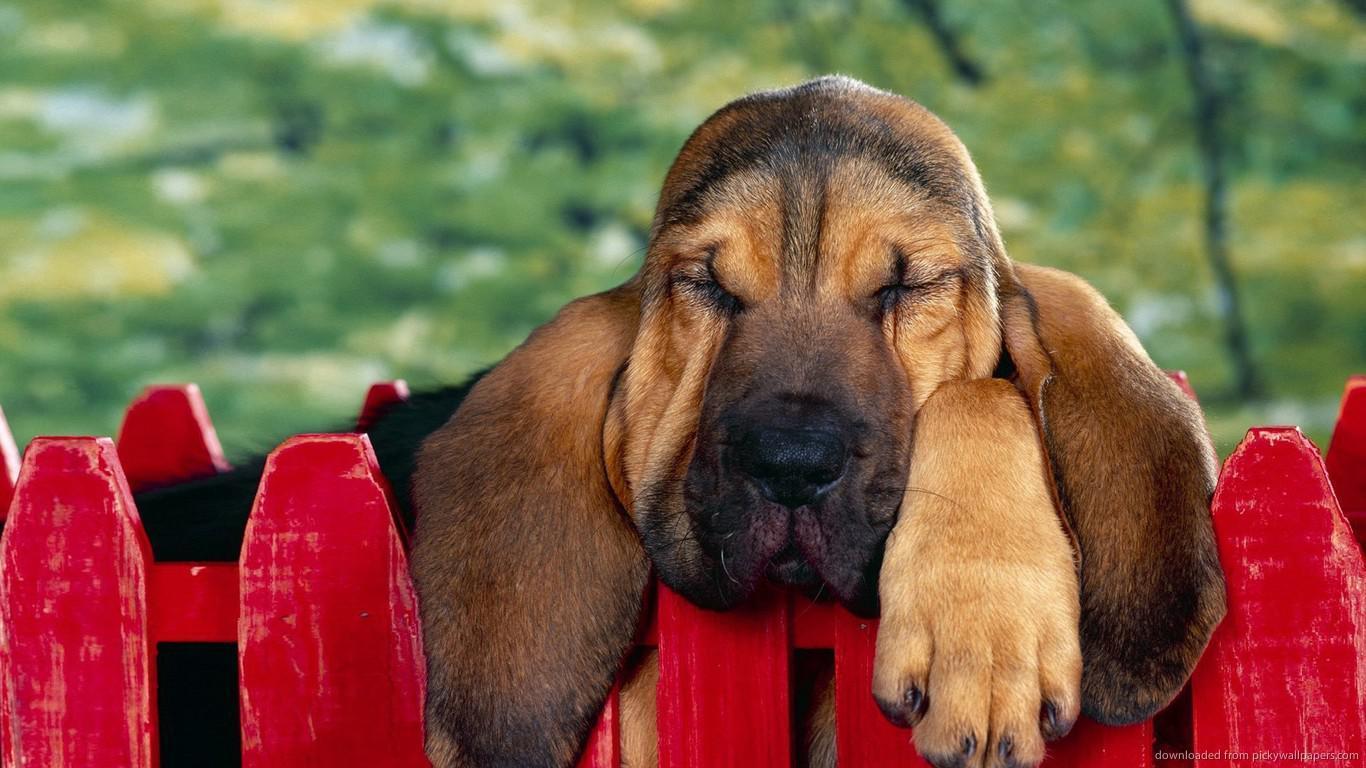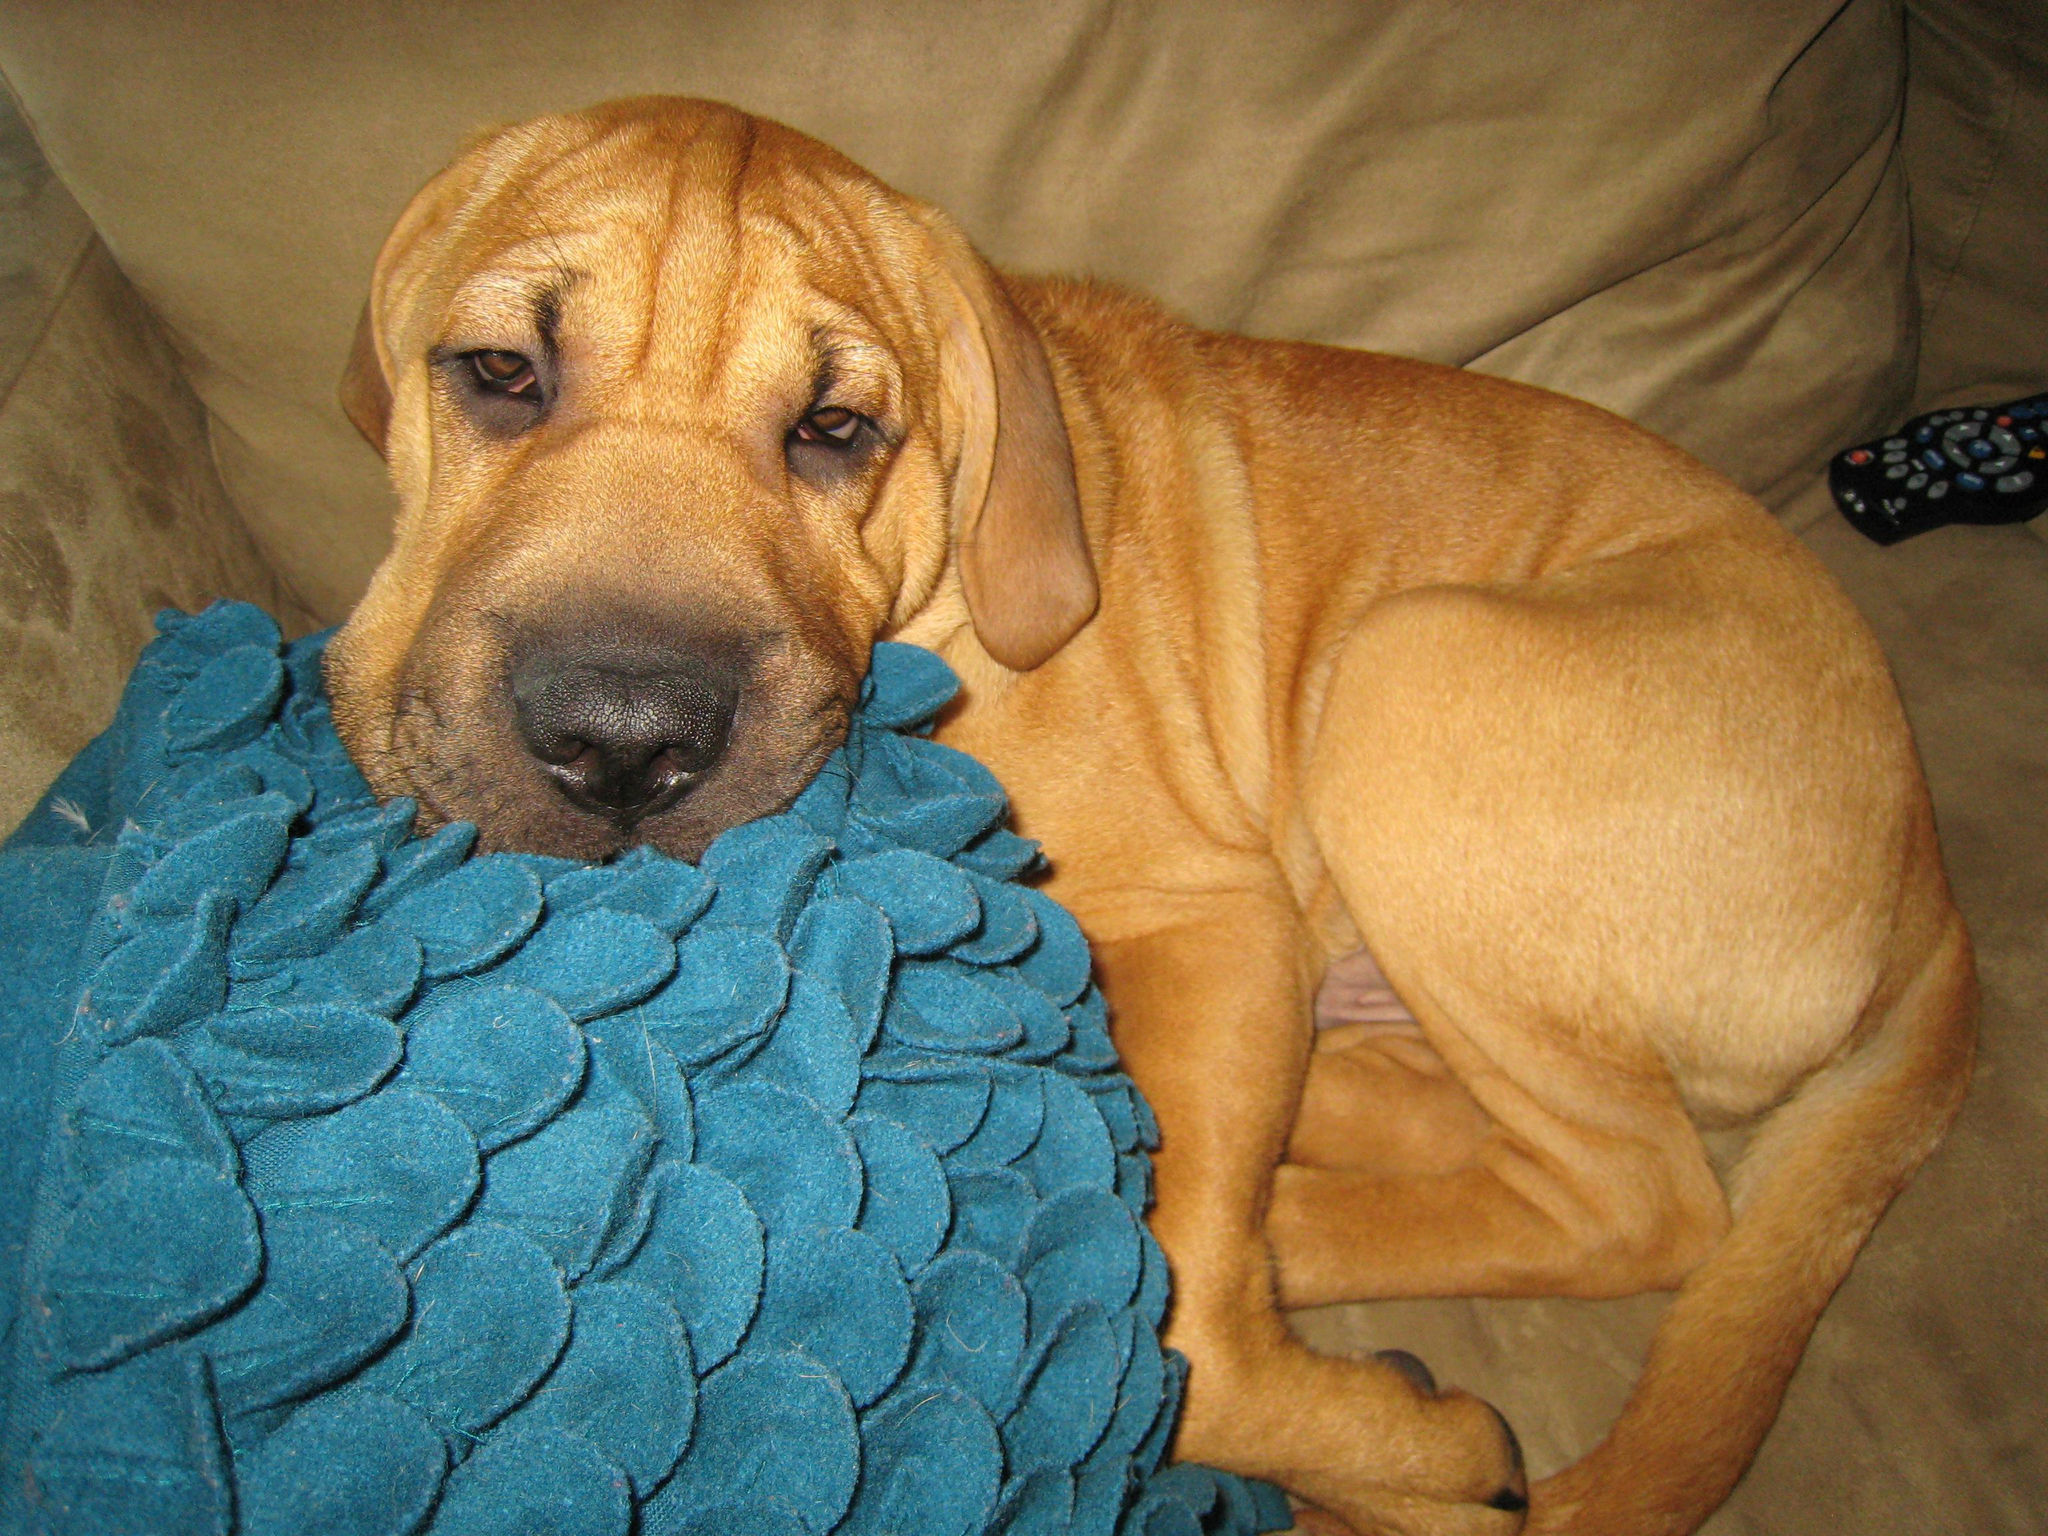The first image is the image on the left, the second image is the image on the right. Given the left and right images, does the statement "a dog has his head on a pillow" hold true? Answer yes or no. Yes. The first image is the image on the left, the second image is the image on the right. Given the left and right images, does the statement "At least one dog is cuddling with a furry friend." hold true? Answer yes or no. No. 